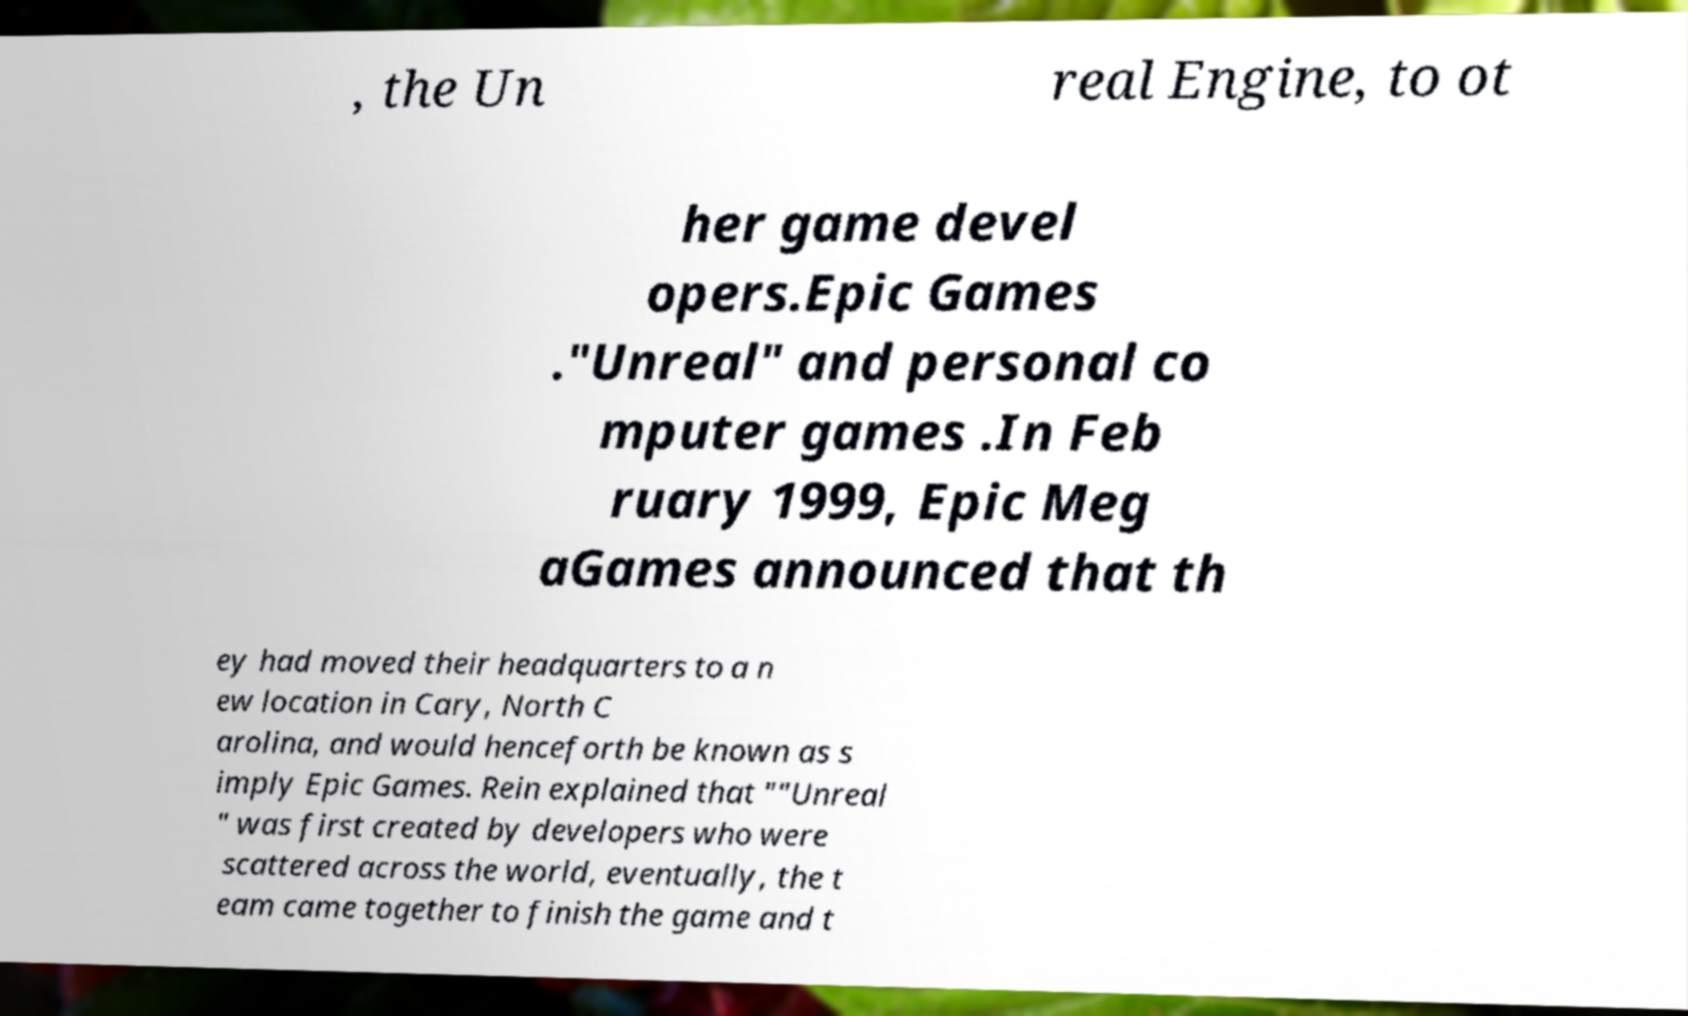Please identify and transcribe the text found in this image. , the Un real Engine, to ot her game devel opers.Epic Games ."Unreal" and personal co mputer games .In Feb ruary 1999, Epic Meg aGames announced that th ey had moved their headquarters to a n ew location in Cary, North C arolina, and would henceforth be known as s imply Epic Games. Rein explained that ""Unreal " was first created by developers who were scattered across the world, eventually, the t eam came together to finish the game and t 